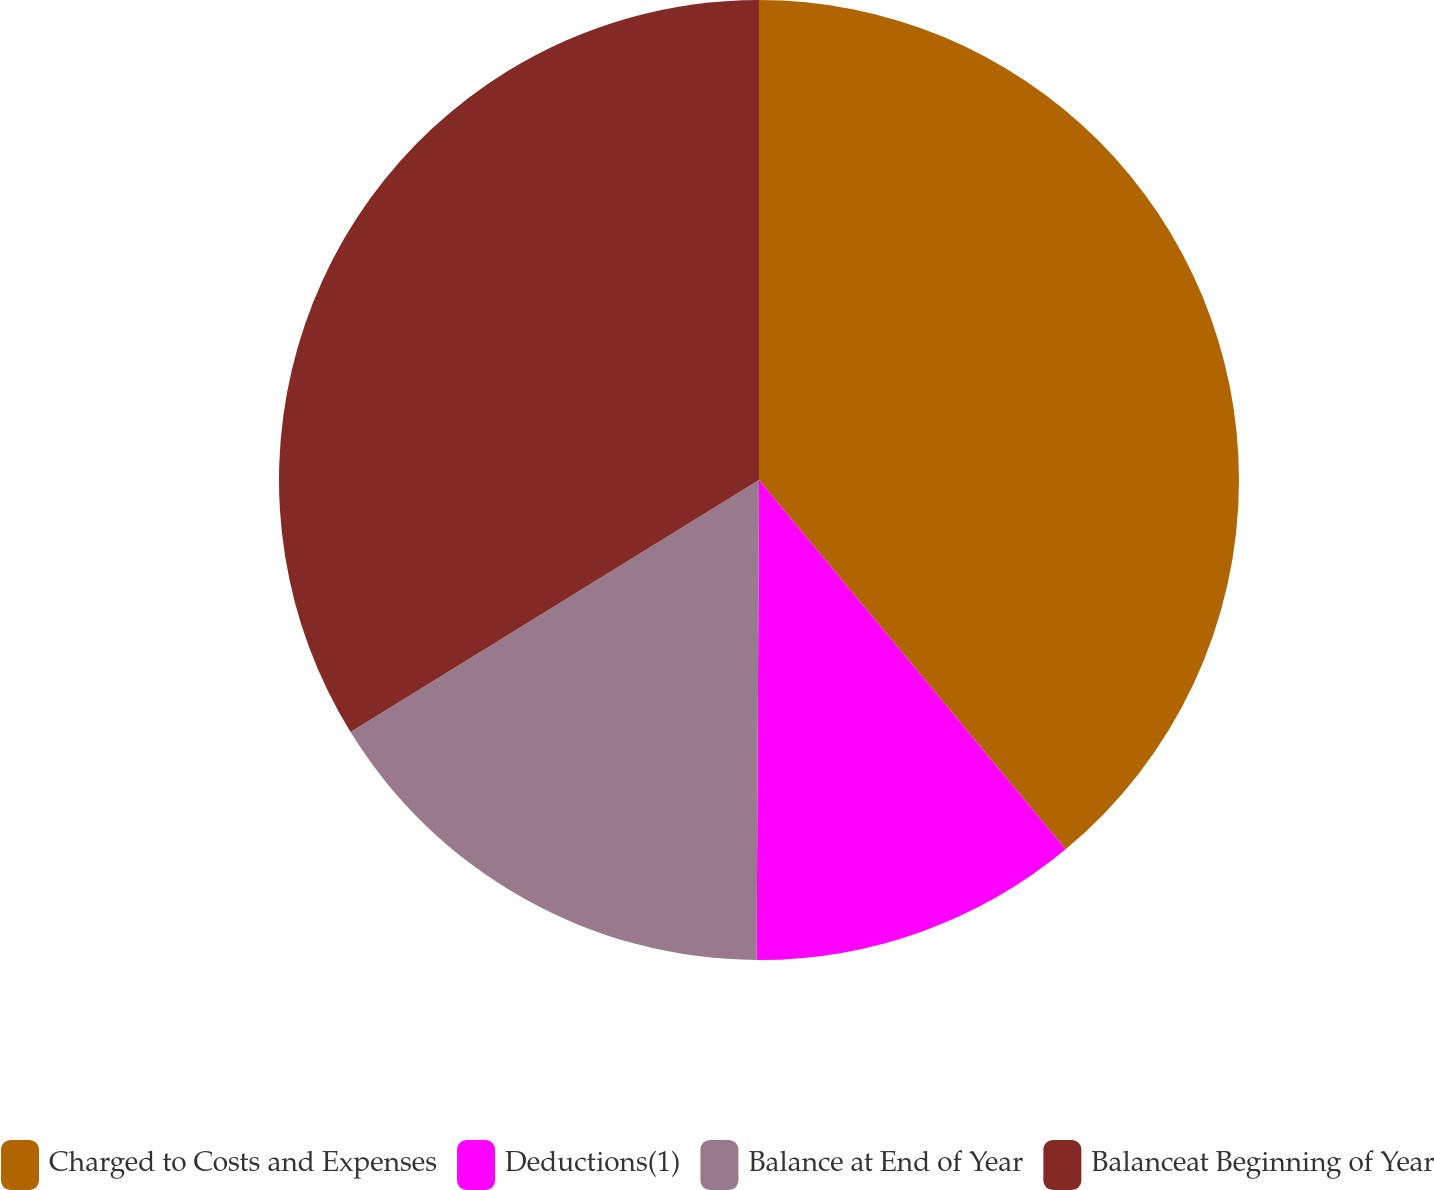Convert chart. <chart><loc_0><loc_0><loc_500><loc_500><pie_chart><fcel>Charged to Costs and Expenses<fcel>Deductions(1)<fcel>Balance at End of Year<fcel>Balanceat Beginning of Year<nl><fcel>38.97%<fcel>11.11%<fcel>16.12%<fcel>33.8%<nl></chart> 